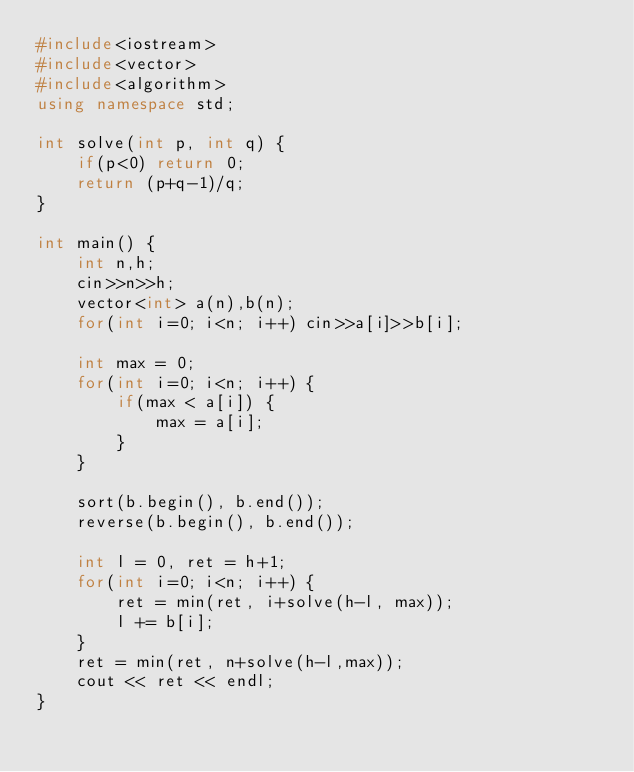<code> <loc_0><loc_0><loc_500><loc_500><_C++_>#include<iostream>
#include<vector>
#include<algorithm>
using namespace std;

int solve(int p, int q) {
    if(p<0) return 0;
    return (p+q-1)/q;
}

int main() {
    int n,h;
    cin>>n>>h;
    vector<int> a(n),b(n);
    for(int i=0; i<n; i++) cin>>a[i]>>b[i];

    int max = 0;
    for(int i=0; i<n; i++) {
        if(max < a[i]) {
            max = a[i];
        }
    }

    sort(b.begin(), b.end());
    reverse(b.begin(), b.end());

    int l = 0, ret = h+1;
    for(int i=0; i<n; i++) {
        ret = min(ret, i+solve(h-l, max));
        l += b[i];
    }
    ret = min(ret, n+solve(h-l,max));
    cout << ret << endl;
}</code> 